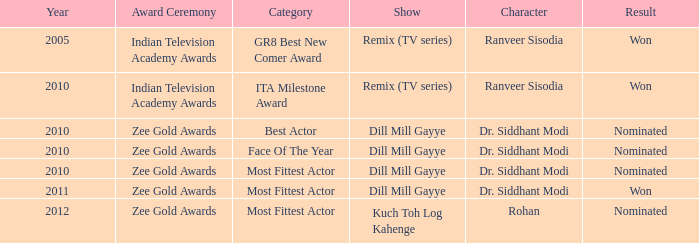Which series includes a character called rohan? Kuch Toh Log Kahenge. 